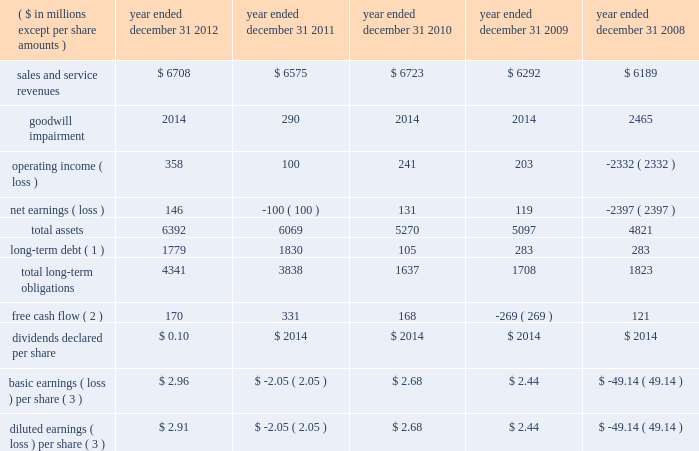Item 6 .
Selected financial data the table represents our selected financial data .
The table should be read in conjunction with item 7 and item 8 of this report .
The table below reflects immaterial error corrections discussed in note 2 : summary of significant accounting policies in item 8. .
Basic earnings ( loss ) per share ( 3 ) $ 2.96 $ ( 2.05 ) $ 2.68 $ 2.44 $ ( 49.14 ) diluted earnings ( loss ) per share ( 3 ) $ 2.91 $ ( 2.05 ) $ 2.68 $ 2.44 $ ( 49.14 ) ( 1 ) long-term debt does not include amounts payable to our former parent as of and before december 31 , 2010 , as these amounts were due upon demand and included in current liabilities .
( 2 ) free cash flow is a non-gaap financial measure and represents cash from operating activities less capital expenditures .
See liquidity and capital resources in item 7 for more information on this measure .
( 3 ) on march 30 , 2011 , the record date of the stock distribution associated with the spin-off from northrop grumman , approximately 48.8 million shares of $ 0.01 par value hii common stock were distributed to northrop grumman stockholders .
This share amount was utilized for the calculation of basic and diluted earnings ( loss ) per share for the three months ended march 31 , 2011 , and all prior periods , as no common stock of the company existed prior to march 30 , 2011 , and the impact of dilutive securities in the three month period ended march 31 , 2011 , was not meaningful. .
What was the net increase in total assets during the 5 year period ? 
Computations: ((6392 - 4821) * 1000000)
Answer: 1571000000.0. 